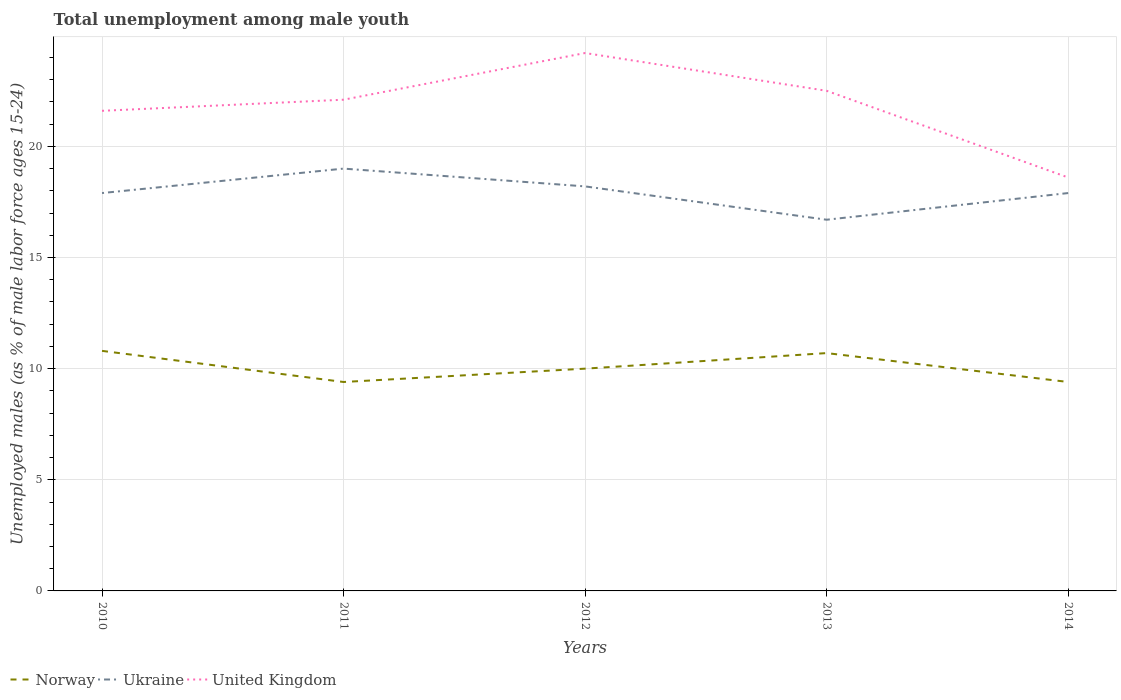How many different coloured lines are there?
Your response must be concise. 3. Does the line corresponding to Ukraine intersect with the line corresponding to Norway?
Provide a succinct answer. No. Is the number of lines equal to the number of legend labels?
Make the answer very short. Yes. Across all years, what is the maximum percentage of unemployed males in in United Kingdom?
Offer a terse response. 18.6. What is the total percentage of unemployed males in in Norway in the graph?
Your answer should be very brief. 0.6. What is the difference between the highest and the second highest percentage of unemployed males in in United Kingdom?
Offer a terse response. 5.6. Is the percentage of unemployed males in in United Kingdom strictly greater than the percentage of unemployed males in in Norway over the years?
Ensure brevity in your answer.  No. How many lines are there?
Provide a succinct answer. 3. What is the difference between two consecutive major ticks on the Y-axis?
Ensure brevity in your answer.  5. Does the graph contain any zero values?
Offer a terse response. No. Does the graph contain grids?
Make the answer very short. Yes. Where does the legend appear in the graph?
Ensure brevity in your answer.  Bottom left. What is the title of the graph?
Keep it short and to the point. Total unemployment among male youth. What is the label or title of the Y-axis?
Keep it short and to the point. Unemployed males (as % of male labor force ages 15-24). What is the Unemployed males (as % of male labor force ages 15-24) in Norway in 2010?
Keep it short and to the point. 10.8. What is the Unemployed males (as % of male labor force ages 15-24) in Ukraine in 2010?
Your response must be concise. 17.9. What is the Unemployed males (as % of male labor force ages 15-24) of United Kingdom in 2010?
Make the answer very short. 21.6. What is the Unemployed males (as % of male labor force ages 15-24) in Norway in 2011?
Offer a very short reply. 9.4. What is the Unemployed males (as % of male labor force ages 15-24) of Ukraine in 2011?
Your response must be concise. 19. What is the Unemployed males (as % of male labor force ages 15-24) of United Kingdom in 2011?
Your answer should be compact. 22.1. What is the Unemployed males (as % of male labor force ages 15-24) of Norway in 2012?
Offer a terse response. 10. What is the Unemployed males (as % of male labor force ages 15-24) of Ukraine in 2012?
Provide a succinct answer. 18.2. What is the Unemployed males (as % of male labor force ages 15-24) in United Kingdom in 2012?
Make the answer very short. 24.2. What is the Unemployed males (as % of male labor force ages 15-24) of Norway in 2013?
Make the answer very short. 10.7. What is the Unemployed males (as % of male labor force ages 15-24) in Ukraine in 2013?
Make the answer very short. 16.7. What is the Unemployed males (as % of male labor force ages 15-24) in Norway in 2014?
Offer a terse response. 9.4. What is the Unemployed males (as % of male labor force ages 15-24) in Ukraine in 2014?
Ensure brevity in your answer.  17.9. What is the Unemployed males (as % of male labor force ages 15-24) of United Kingdom in 2014?
Your response must be concise. 18.6. Across all years, what is the maximum Unemployed males (as % of male labor force ages 15-24) in Norway?
Your answer should be very brief. 10.8. Across all years, what is the maximum Unemployed males (as % of male labor force ages 15-24) in United Kingdom?
Make the answer very short. 24.2. Across all years, what is the minimum Unemployed males (as % of male labor force ages 15-24) in Norway?
Provide a succinct answer. 9.4. Across all years, what is the minimum Unemployed males (as % of male labor force ages 15-24) in Ukraine?
Keep it short and to the point. 16.7. Across all years, what is the minimum Unemployed males (as % of male labor force ages 15-24) in United Kingdom?
Your answer should be compact. 18.6. What is the total Unemployed males (as % of male labor force ages 15-24) of Norway in the graph?
Your answer should be very brief. 50.3. What is the total Unemployed males (as % of male labor force ages 15-24) in Ukraine in the graph?
Offer a very short reply. 89.7. What is the total Unemployed males (as % of male labor force ages 15-24) of United Kingdom in the graph?
Provide a short and direct response. 109. What is the difference between the Unemployed males (as % of male labor force ages 15-24) of Norway in 2010 and that in 2011?
Your response must be concise. 1.4. What is the difference between the Unemployed males (as % of male labor force ages 15-24) in Ukraine in 2010 and that in 2011?
Provide a succinct answer. -1.1. What is the difference between the Unemployed males (as % of male labor force ages 15-24) of United Kingdom in 2010 and that in 2011?
Keep it short and to the point. -0.5. What is the difference between the Unemployed males (as % of male labor force ages 15-24) of Norway in 2010 and that in 2013?
Give a very brief answer. 0.1. What is the difference between the Unemployed males (as % of male labor force ages 15-24) of United Kingdom in 2010 and that in 2013?
Provide a succinct answer. -0.9. What is the difference between the Unemployed males (as % of male labor force ages 15-24) in Ukraine in 2010 and that in 2014?
Provide a succinct answer. 0. What is the difference between the Unemployed males (as % of male labor force ages 15-24) in United Kingdom in 2010 and that in 2014?
Give a very brief answer. 3. What is the difference between the Unemployed males (as % of male labor force ages 15-24) of United Kingdom in 2011 and that in 2012?
Make the answer very short. -2.1. What is the difference between the Unemployed males (as % of male labor force ages 15-24) in Norway in 2012 and that in 2013?
Your answer should be compact. -0.7. What is the difference between the Unemployed males (as % of male labor force ages 15-24) in Ukraine in 2012 and that in 2013?
Offer a very short reply. 1.5. What is the difference between the Unemployed males (as % of male labor force ages 15-24) of United Kingdom in 2012 and that in 2013?
Your answer should be compact. 1.7. What is the difference between the Unemployed males (as % of male labor force ages 15-24) of Norway in 2012 and that in 2014?
Provide a short and direct response. 0.6. What is the difference between the Unemployed males (as % of male labor force ages 15-24) in Norway in 2013 and that in 2014?
Ensure brevity in your answer.  1.3. What is the difference between the Unemployed males (as % of male labor force ages 15-24) in Norway in 2010 and the Unemployed males (as % of male labor force ages 15-24) in Ukraine in 2011?
Your answer should be very brief. -8.2. What is the difference between the Unemployed males (as % of male labor force ages 15-24) in Norway in 2010 and the Unemployed males (as % of male labor force ages 15-24) in Ukraine in 2013?
Your response must be concise. -5.9. What is the difference between the Unemployed males (as % of male labor force ages 15-24) in Norway in 2010 and the Unemployed males (as % of male labor force ages 15-24) in United Kingdom in 2013?
Provide a short and direct response. -11.7. What is the difference between the Unemployed males (as % of male labor force ages 15-24) in Ukraine in 2010 and the Unemployed males (as % of male labor force ages 15-24) in United Kingdom in 2013?
Your answer should be very brief. -4.6. What is the difference between the Unemployed males (as % of male labor force ages 15-24) in Norway in 2010 and the Unemployed males (as % of male labor force ages 15-24) in Ukraine in 2014?
Your answer should be very brief. -7.1. What is the difference between the Unemployed males (as % of male labor force ages 15-24) of Ukraine in 2010 and the Unemployed males (as % of male labor force ages 15-24) of United Kingdom in 2014?
Your answer should be compact. -0.7. What is the difference between the Unemployed males (as % of male labor force ages 15-24) in Norway in 2011 and the Unemployed males (as % of male labor force ages 15-24) in Ukraine in 2012?
Your response must be concise. -8.8. What is the difference between the Unemployed males (as % of male labor force ages 15-24) in Norway in 2011 and the Unemployed males (as % of male labor force ages 15-24) in United Kingdom in 2012?
Your answer should be very brief. -14.8. What is the difference between the Unemployed males (as % of male labor force ages 15-24) in Ukraine in 2011 and the Unemployed males (as % of male labor force ages 15-24) in United Kingdom in 2012?
Your answer should be very brief. -5.2. What is the difference between the Unemployed males (as % of male labor force ages 15-24) of Norway in 2011 and the Unemployed males (as % of male labor force ages 15-24) of Ukraine in 2013?
Your response must be concise. -7.3. What is the difference between the Unemployed males (as % of male labor force ages 15-24) in Ukraine in 2011 and the Unemployed males (as % of male labor force ages 15-24) in United Kingdom in 2013?
Offer a terse response. -3.5. What is the difference between the Unemployed males (as % of male labor force ages 15-24) of Norway in 2011 and the Unemployed males (as % of male labor force ages 15-24) of Ukraine in 2014?
Offer a terse response. -8.5. What is the difference between the Unemployed males (as % of male labor force ages 15-24) of Norway in 2011 and the Unemployed males (as % of male labor force ages 15-24) of United Kingdom in 2014?
Your answer should be compact. -9.2. What is the difference between the Unemployed males (as % of male labor force ages 15-24) in Norway in 2012 and the Unemployed males (as % of male labor force ages 15-24) in Ukraine in 2013?
Make the answer very short. -6.7. What is the difference between the Unemployed males (as % of male labor force ages 15-24) in Norway in 2012 and the Unemployed males (as % of male labor force ages 15-24) in Ukraine in 2014?
Make the answer very short. -7.9. What is the difference between the Unemployed males (as % of male labor force ages 15-24) of Norway in 2012 and the Unemployed males (as % of male labor force ages 15-24) of United Kingdom in 2014?
Make the answer very short. -8.6. What is the difference between the Unemployed males (as % of male labor force ages 15-24) in Ukraine in 2013 and the Unemployed males (as % of male labor force ages 15-24) in United Kingdom in 2014?
Provide a short and direct response. -1.9. What is the average Unemployed males (as % of male labor force ages 15-24) in Norway per year?
Your answer should be very brief. 10.06. What is the average Unemployed males (as % of male labor force ages 15-24) in Ukraine per year?
Provide a short and direct response. 17.94. What is the average Unemployed males (as % of male labor force ages 15-24) of United Kingdom per year?
Offer a terse response. 21.8. In the year 2010, what is the difference between the Unemployed males (as % of male labor force ages 15-24) in Ukraine and Unemployed males (as % of male labor force ages 15-24) in United Kingdom?
Make the answer very short. -3.7. In the year 2011, what is the difference between the Unemployed males (as % of male labor force ages 15-24) in Norway and Unemployed males (as % of male labor force ages 15-24) in Ukraine?
Offer a terse response. -9.6. In the year 2011, what is the difference between the Unemployed males (as % of male labor force ages 15-24) of Norway and Unemployed males (as % of male labor force ages 15-24) of United Kingdom?
Your answer should be compact. -12.7. In the year 2013, what is the difference between the Unemployed males (as % of male labor force ages 15-24) of Ukraine and Unemployed males (as % of male labor force ages 15-24) of United Kingdom?
Your answer should be very brief. -5.8. In the year 2014, what is the difference between the Unemployed males (as % of male labor force ages 15-24) of Norway and Unemployed males (as % of male labor force ages 15-24) of Ukraine?
Make the answer very short. -8.5. In the year 2014, what is the difference between the Unemployed males (as % of male labor force ages 15-24) of Norway and Unemployed males (as % of male labor force ages 15-24) of United Kingdom?
Provide a short and direct response. -9.2. What is the ratio of the Unemployed males (as % of male labor force ages 15-24) of Norway in 2010 to that in 2011?
Offer a terse response. 1.15. What is the ratio of the Unemployed males (as % of male labor force ages 15-24) of Ukraine in 2010 to that in 2011?
Give a very brief answer. 0.94. What is the ratio of the Unemployed males (as % of male labor force ages 15-24) of United Kingdom in 2010 to that in 2011?
Offer a very short reply. 0.98. What is the ratio of the Unemployed males (as % of male labor force ages 15-24) of Norway in 2010 to that in 2012?
Keep it short and to the point. 1.08. What is the ratio of the Unemployed males (as % of male labor force ages 15-24) of Ukraine in 2010 to that in 2012?
Give a very brief answer. 0.98. What is the ratio of the Unemployed males (as % of male labor force ages 15-24) of United Kingdom in 2010 to that in 2012?
Offer a terse response. 0.89. What is the ratio of the Unemployed males (as % of male labor force ages 15-24) of Norway in 2010 to that in 2013?
Your response must be concise. 1.01. What is the ratio of the Unemployed males (as % of male labor force ages 15-24) of Ukraine in 2010 to that in 2013?
Your response must be concise. 1.07. What is the ratio of the Unemployed males (as % of male labor force ages 15-24) of United Kingdom in 2010 to that in 2013?
Provide a succinct answer. 0.96. What is the ratio of the Unemployed males (as % of male labor force ages 15-24) in Norway in 2010 to that in 2014?
Your answer should be compact. 1.15. What is the ratio of the Unemployed males (as % of male labor force ages 15-24) in United Kingdom in 2010 to that in 2014?
Your answer should be very brief. 1.16. What is the ratio of the Unemployed males (as % of male labor force ages 15-24) in Ukraine in 2011 to that in 2012?
Ensure brevity in your answer.  1.04. What is the ratio of the Unemployed males (as % of male labor force ages 15-24) of United Kingdom in 2011 to that in 2012?
Make the answer very short. 0.91. What is the ratio of the Unemployed males (as % of male labor force ages 15-24) in Norway in 2011 to that in 2013?
Give a very brief answer. 0.88. What is the ratio of the Unemployed males (as % of male labor force ages 15-24) of Ukraine in 2011 to that in 2013?
Provide a short and direct response. 1.14. What is the ratio of the Unemployed males (as % of male labor force ages 15-24) in United Kingdom in 2011 to that in 2013?
Keep it short and to the point. 0.98. What is the ratio of the Unemployed males (as % of male labor force ages 15-24) in Ukraine in 2011 to that in 2014?
Your answer should be compact. 1.06. What is the ratio of the Unemployed males (as % of male labor force ages 15-24) in United Kingdom in 2011 to that in 2014?
Give a very brief answer. 1.19. What is the ratio of the Unemployed males (as % of male labor force ages 15-24) of Norway in 2012 to that in 2013?
Keep it short and to the point. 0.93. What is the ratio of the Unemployed males (as % of male labor force ages 15-24) in Ukraine in 2012 to that in 2013?
Offer a terse response. 1.09. What is the ratio of the Unemployed males (as % of male labor force ages 15-24) in United Kingdom in 2012 to that in 2013?
Your answer should be compact. 1.08. What is the ratio of the Unemployed males (as % of male labor force ages 15-24) of Norway in 2012 to that in 2014?
Provide a succinct answer. 1.06. What is the ratio of the Unemployed males (as % of male labor force ages 15-24) in Ukraine in 2012 to that in 2014?
Your response must be concise. 1.02. What is the ratio of the Unemployed males (as % of male labor force ages 15-24) of United Kingdom in 2012 to that in 2014?
Your answer should be very brief. 1.3. What is the ratio of the Unemployed males (as % of male labor force ages 15-24) in Norway in 2013 to that in 2014?
Keep it short and to the point. 1.14. What is the ratio of the Unemployed males (as % of male labor force ages 15-24) of Ukraine in 2013 to that in 2014?
Your answer should be compact. 0.93. What is the ratio of the Unemployed males (as % of male labor force ages 15-24) in United Kingdom in 2013 to that in 2014?
Ensure brevity in your answer.  1.21. What is the difference between the highest and the second highest Unemployed males (as % of male labor force ages 15-24) of Norway?
Ensure brevity in your answer.  0.1. What is the difference between the highest and the second highest Unemployed males (as % of male labor force ages 15-24) in Ukraine?
Offer a terse response. 0.8. What is the difference between the highest and the lowest Unemployed males (as % of male labor force ages 15-24) in Ukraine?
Your answer should be compact. 2.3. 